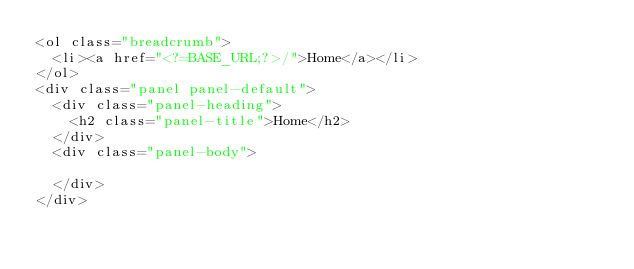<code> <loc_0><loc_0><loc_500><loc_500><_PHP_><ol class="breadcrumb">
	<li><a href="<?=BASE_URL;?>/">Home</a></li>
</ol>
<div class="panel panel-default">
	<div class="panel-heading">
		<h2 class="panel-title">Home</h2>
	</div>
	<div class="panel-body">
		
	</div>
</div></code> 